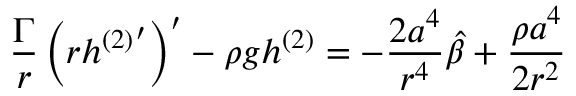<formula> <loc_0><loc_0><loc_500><loc_500>\frac { \Gamma } { r } \left ( r h { ^ { ( 2 ) } } ^ { \prime } \right ) ^ { \prime } - \rho { g } h ^ { ( 2 ) } = - \frac { 2 a ^ { 4 } } { r ^ { 4 } } \hat { \beta } + \frac { \rho { a } ^ { 4 } } { 2 r ^ { 2 } }</formula> 